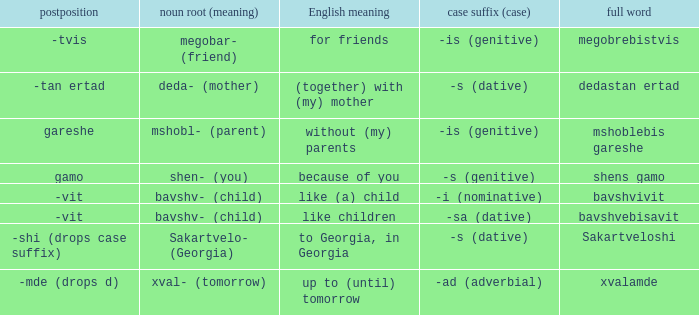What is Case Suffix (Case), when Postposition is "-mde (drops d)"? -ad (adverbial). 